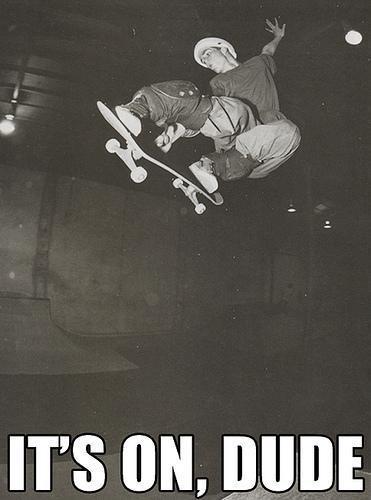How many people are in the picture?
Give a very brief answer. 2. How many people have remotes in their hands?
Give a very brief answer. 0. 